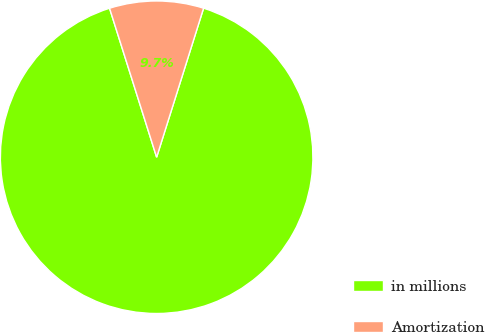<chart> <loc_0><loc_0><loc_500><loc_500><pie_chart><fcel>in millions<fcel>Amortization<nl><fcel>90.27%<fcel>9.73%<nl></chart> 